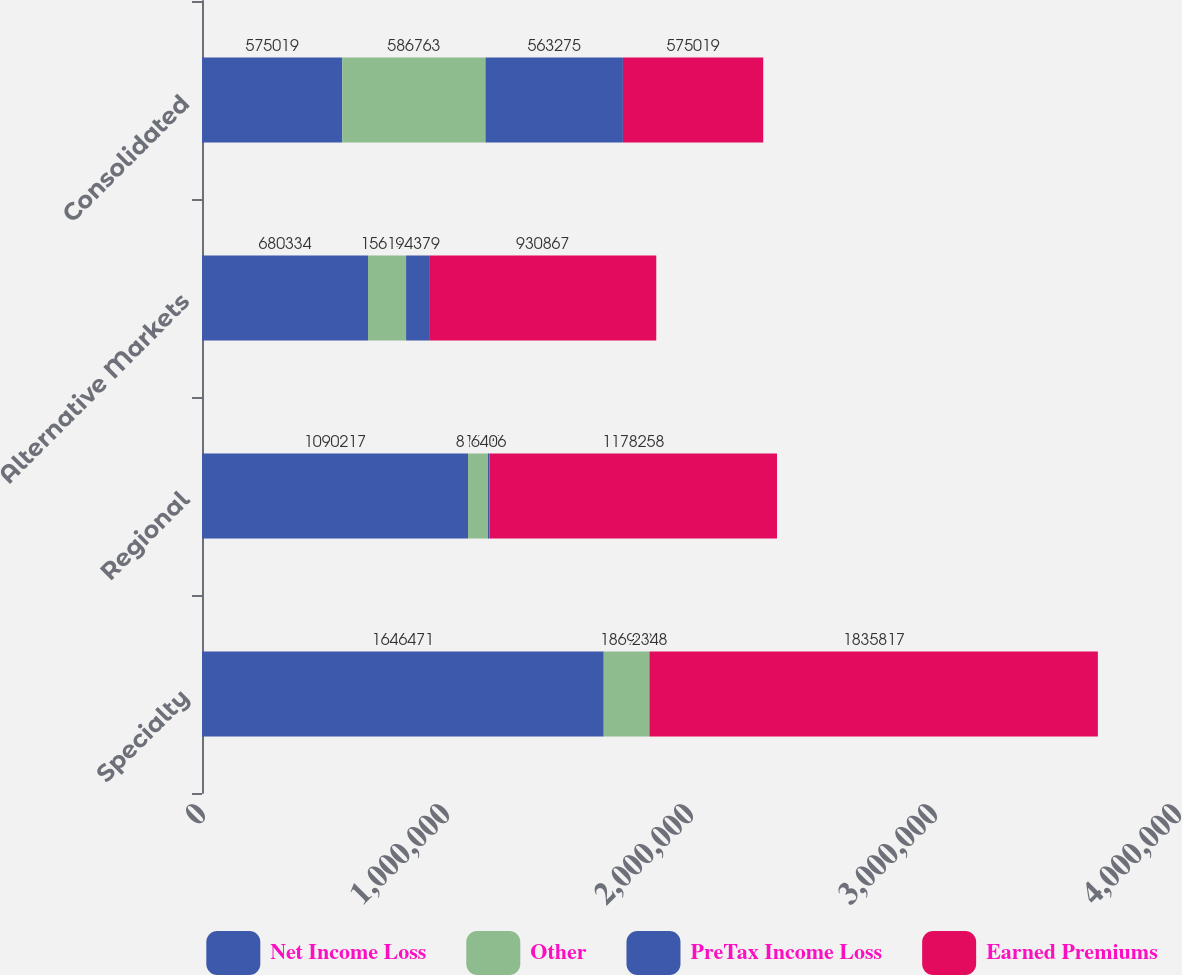Convert chart to OTSL. <chart><loc_0><loc_0><loc_500><loc_500><stacked_bar_chart><ecel><fcel>Specialty<fcel>Regional<fcel>Alternative Markets<fcel>Consolidated<nl><fcel>Net Income Loss<fcel>1.64647e+06<fcel>1.09022e+06<fcel>680334<fcel>575019<nl><fcel>Other<fcel>186998<fcel>81635<fcel>156154<fcel>586763<nl><fcel>PreTax Income Loss<fcel>2348<fcel>6406<fcel>94379<fcel>563275<nl><fcel>Earned Premiums<fcel>1.83582e+06<fcel>1.17826e+06<fcel>930867<fcel>575019<nl></chart> 